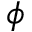Convert formula to latex. <formula><loc_0><loc_0><loc_500><loc_500>\phi</formula> 